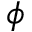Convert formula to latex. <formula><loc_0><loc_0><loc_500><loc_500>\phi</formula> 